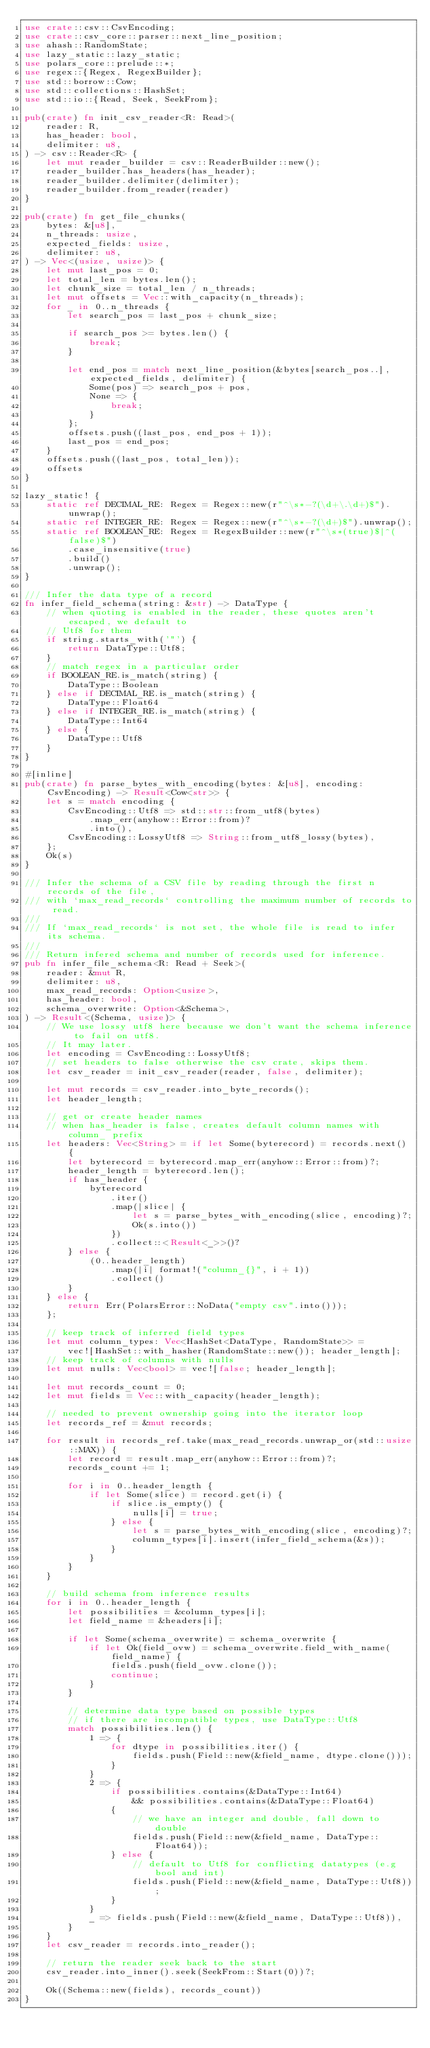Convert code to text. <code><loc_0><loc_0><loc_500><loc_500><_Rust_>use crate::csv::CsvEncoding;
use crate::csv_core::parser::next_line_position;
use ahash::RandomState;
use lazy_static::lazy_static;
use polars_core::prelude::*;
use regex::{Regex, RegexBuilder};
use std::borrow::Cow;
use std::collections::HashSet;
use std::io::{Read, Seek, SeekFrom};

pub(crate) fn init_csv_reader<R: Read>(
    reader: R,
    has_header: bool,
    delimiter: u8,
) -> csv::Reader<R> {
    let mut reader_builder = csv::ReaderBuilder::new();
    reader_builder.has_headers(has_header);
    reader_builder.delimiter(delimiter);
    reader_builder.from_reader(reader)
}

pub(crate) fn get_file_chunks(
    bytes: &[u8],
    n_threads: usize,
    expected_fields: usize,
    delimiter: u8,
) -> Vec<(usize, usize)> {
    let mut last_pos = 0;
    let total_len = bytes.len();
    let chunk_size = total_len / n_threads;
    let mut offsets = Vec::with_capacity(n_threads);
    for _ in 0..n_threads {
        let search_pos = last_pos + chunk_size;

        if search_pos >= bytes.len() {
            break;
        }

        let end_pos = match next_line_position(&bytes[search_pos..], expected_fields, delimiter) {
            Some(pos) => search_pos + pos,
            None => {
                break;
            }
        };
        offsets.push((last_pos, end_pos + 1));
        last_pos = end_pos;
    }
    offsets.push((last_pos, total_len));
    offsets
}

lazy_static! {
    static ref DECIMAL_RE: Regex = Regex::new(r"^\s*-?(\d+\.\d+)$").unwrap();
    static ref INTEGER_RE: Regex = Regex::new(r"^\s*-?(\d+)$").unwrap();
    static ref BOOLEAN_RE: Regex = RegexBuilder::new(r"^\s*(true)$|^(false)$")
        .case_insensitive(true)
        .build()
        .unwrap();
}

/// Infer the data type of a record
fn infer_field_schema(string: &str) -> DataType {
    // when quoting is enabled in the reader, these quotes aren't escaped, we default to
    // Utf8 for them
    if string.starts_with('"') {
        return DataType::Utf8;
    }
    // match regex in a particular order
    if BOOLEAN_RE.is_match(string) {
        DataType::Boolean
    } else if DECIMAL_RE.is_match(string) {
        DataType::Float64
    } else if INTEGER_RE.is_match(string) {
        DataType::Int64
    } else {
        DataType::Utf8
    }
}

#[inline]
pub(crate) fn parse_bytes_with_encoding(bytes: &[u8], encoding: CsvEncoding) -> Result<Cow<str>> {
    let s = match encoding {
        CsvEncoding::Utf8 => std::str::from_utf8(bytes)
            .map_err(anyhow::Error::from)?
            .into(),
        CsvEncoding::LossyUtf8 => String::from_utf8_lossy(bytes),
    };
    Ok(s)
}

/// Infer the schema of a CSV file by reading through the first n records of the file,
/// with `max_read_records` controlling the maximum number of records to read.
///
/// If `max_read_records` is not set, the whole file is read to infer its schema.
///
/// Return infered schema and number of records used for inference.
pub fn infer_file_schema<R: Read + Seek>(
    reader: &mut R,
    delimiter: u8,
    max_read_records: Option<usize>,
    has_header: bool,
    schema_overwrite: Option<&Schema>,
) -> Result<(Schema, usize)> {
    // We use lossy utf8 here because we don't want the schema inference to fail on utf8.
    // It may later.
    let encoding = CsvEncoding::LossyUtf8;
    // set headers to false otherwise the csv crate, skips them.
    let csv_reader = init_csv_reader(reader, false, delimiter);

    let mut records = csv_reader.into_byte_records();
    let header_length;

    // get or create header names
    // when has_header is false, creates default column names with column_ prefix
    let headers: Vec<String> = if let Some(byterecord) = records.next() {
        let byterecord = byterecord.map_err(anyhow::Error::from)?;
        header_length = byterecord.len();
        if has_header {
            byterecord
                .iter()
                .map(|slice| {
                    let s = parse_bytes_with_encoding(slice, encoding)?;
                    Ok(s.into())
                })
                .collect::<Result<_>>()?
        } else {
            (0..header_length)
                .map(|i| format!("column_{}", i + 1))
                .collect()
        }
    } else {
        return Err(PolarsError::NoData("empty csv".into()));
    };

    // keep track of inferred field types
    let mut column_types: Vec<HashSet<DataType, RandomState>> =
        vec![HashSet::with_hasher(RandomState::new()); header_length];
    // keep track of columns with nulls
    let mut nulls: Vec<bool> = vec![false; header_length];

    let mut records_count = 0;
    let mut fields = Vec::with_capacity(header_length);

    // needed to prevent ownership going into the iterator loop
    let records_ref = &mut records;

    for result in records_ref.take(max_read_records.unwrap_or(std::usize::MAX)) {
        let record = result.map_err(anyhow::Error::from)?;
        records_count += 1;

        for i in 0..header_length {
            if let Some(slice) = record.get(i) {
                if slice.is_empty() {
                    nulls[i] = true;
                } else {
                    let s = parse_bytes_with_encoding(slice, encoding)?;
                    column_types[i].insert(infer_field_schema(&s));
                }
            }
        }
    }

    // build schema from inference results
    for i in 0..header_length {
        let possibilities = &column_types[i];
        let field_name = &headers[i];

        if let Some(schema_overwrite) = schema_overwrite {
            if let Ok(field_ovw) = schema_overwrite.field_with_name(field_name) {
                fields.push(field_ovw.clone());
                continue;
            }
        }

        // determine data type based on possible types
        // if there are incompatible types, use DataType::Utf8
        match possibilities.len() {
            1 => {
                for dtype in possibilities.iter() {
                    fields.push(Field::new(&field_name, dtype.clone()));
                }
            }
            2 => {
                if possibilities.contains(&DataType::Int64)
                    && possibilities.contains(&DataType::Float64)
                {
                    // we have an integer and double, fall down to double
                    fields.push(Field::new(&field_name, DataType::Float64));
                } else {
                    // default to Utf8 for conflicting datatypes (e.g bool and int)
                    fields.push(Field::new(&field_name, DataType::Utf8));
                }
            }
            _ => fields.push(Field::new(&field_name, DataType::Utf8)),
        }
    }
    let csv_reader = records.into_reader();

    // return the reader seek back to the start
    csv_reader.into_inner().seek(SeekFrom::Start(0))?;

    Ok((Schema::new(fields), records_count))
}
</code> 